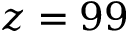<formula> <loc_0><loc_0><loc_500><loc_500>z = 9 9</formula> 